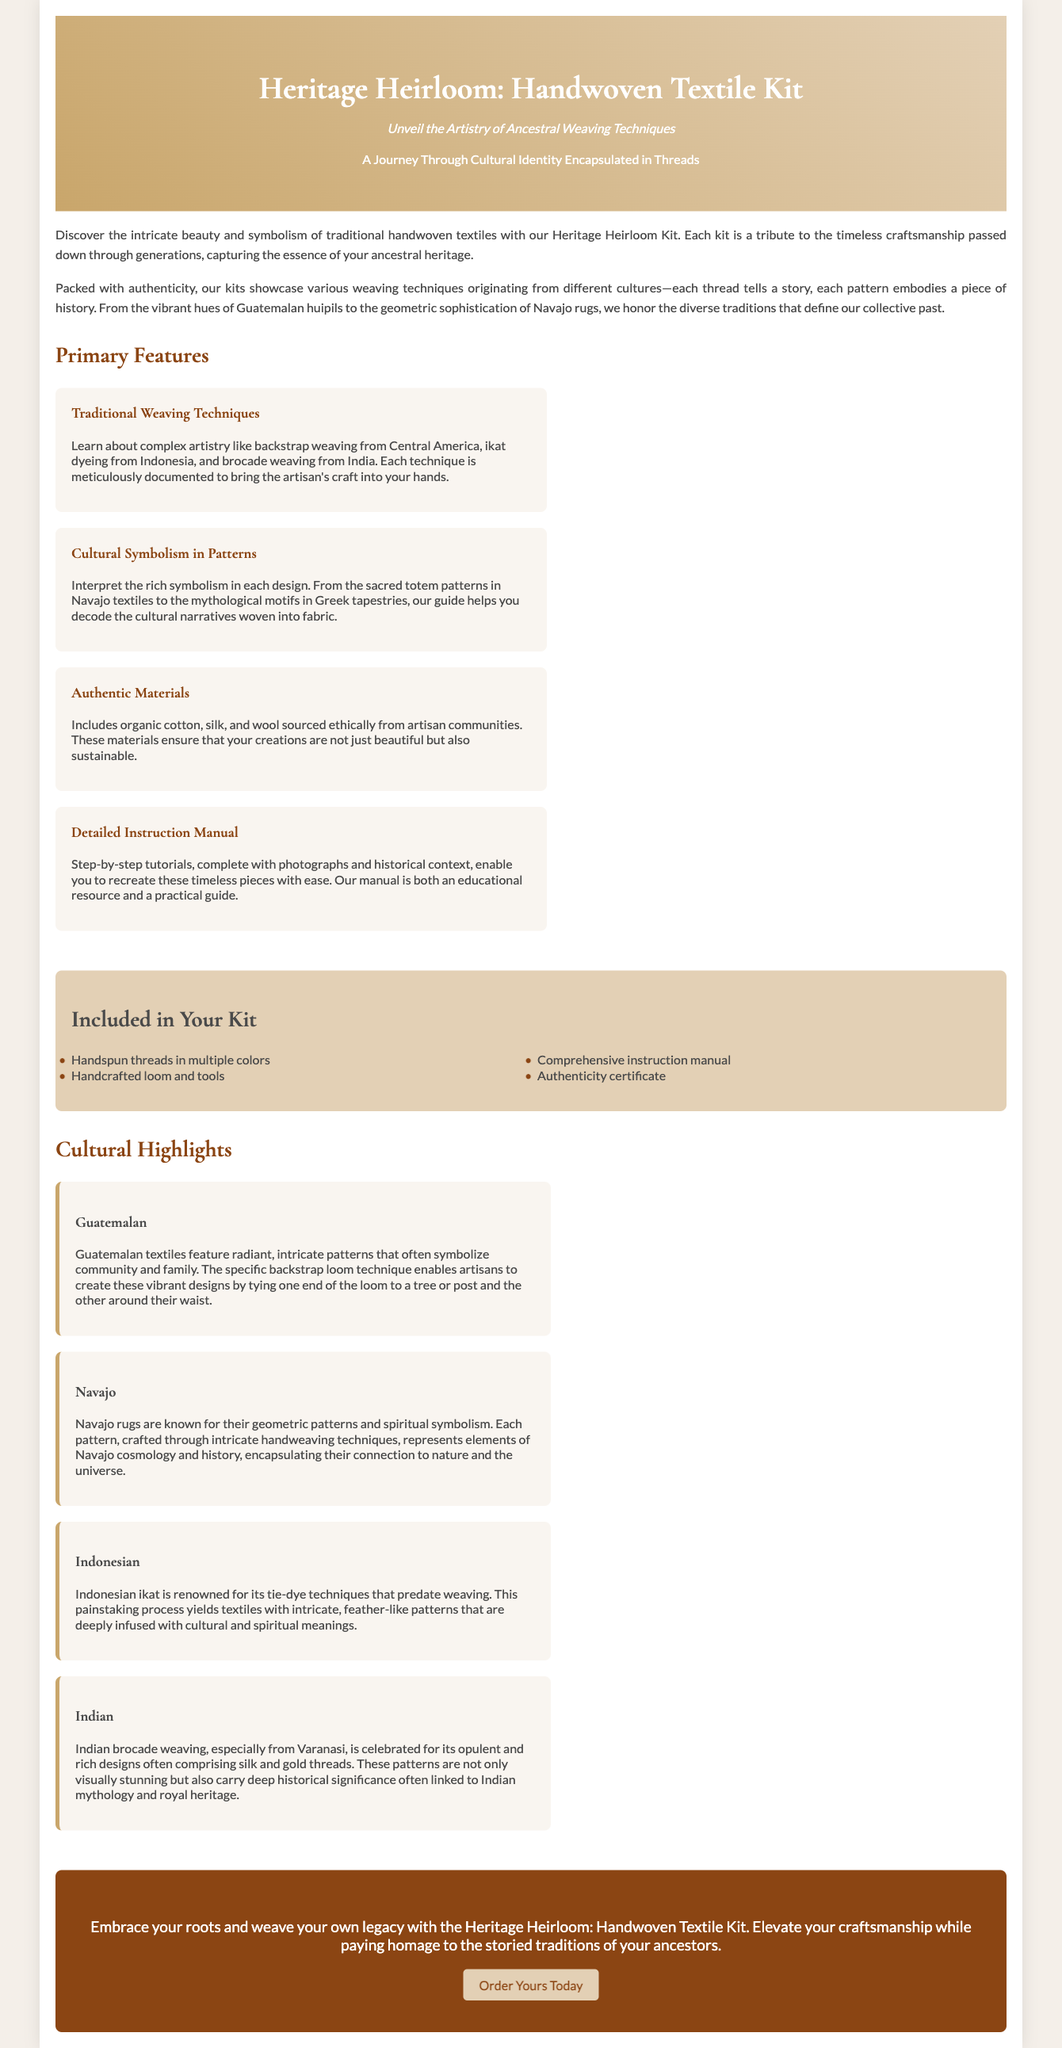What is the title of the kit? The title is prominently displayed in the header of the document, which is "Heritage Heirloom: Handwoven Textile Kit."
Answer: Heritage Heirloom: Handwoven Textile Kit What traditional weaving technique is mentioned from Central America? The document mentions backstrap weaving as a traditional technique from Central America.
Answer: Backstrap weaving How many cultural highlights are included in the kit description? The document lists a total of four cultural highlights related to different regions and their weaving techniques.
Answer: Four Which material is specifically cited as organic in the kit contents? The document mentions organic cotton as one of the materials included in the kit.
Answer: Organic cotton What kind of loom is provided in the kit? The kit includes a handcrafted loom among its contents as stated in the list.
Answer: Handcrafted loom How does the Guatemalan textile weaving technique involve the artisan? The description explains that the artisan ties one end of the loom to a tree or post and the other around their waist for weaving.
Answer: Ties one end to a tree or post What is the purpose of the instruction manual in the kit? The instruction manual is designed to offer step-by-step tutorials complete with photographs and historical context for recreating the pieces.
Answer: Step-by-step tutorials What do Navajo rugs represent in their patterns? The document notes that each Navajo rug pattern represents elements of Navajo cosmology and history.
Answer: Cosmology and history 